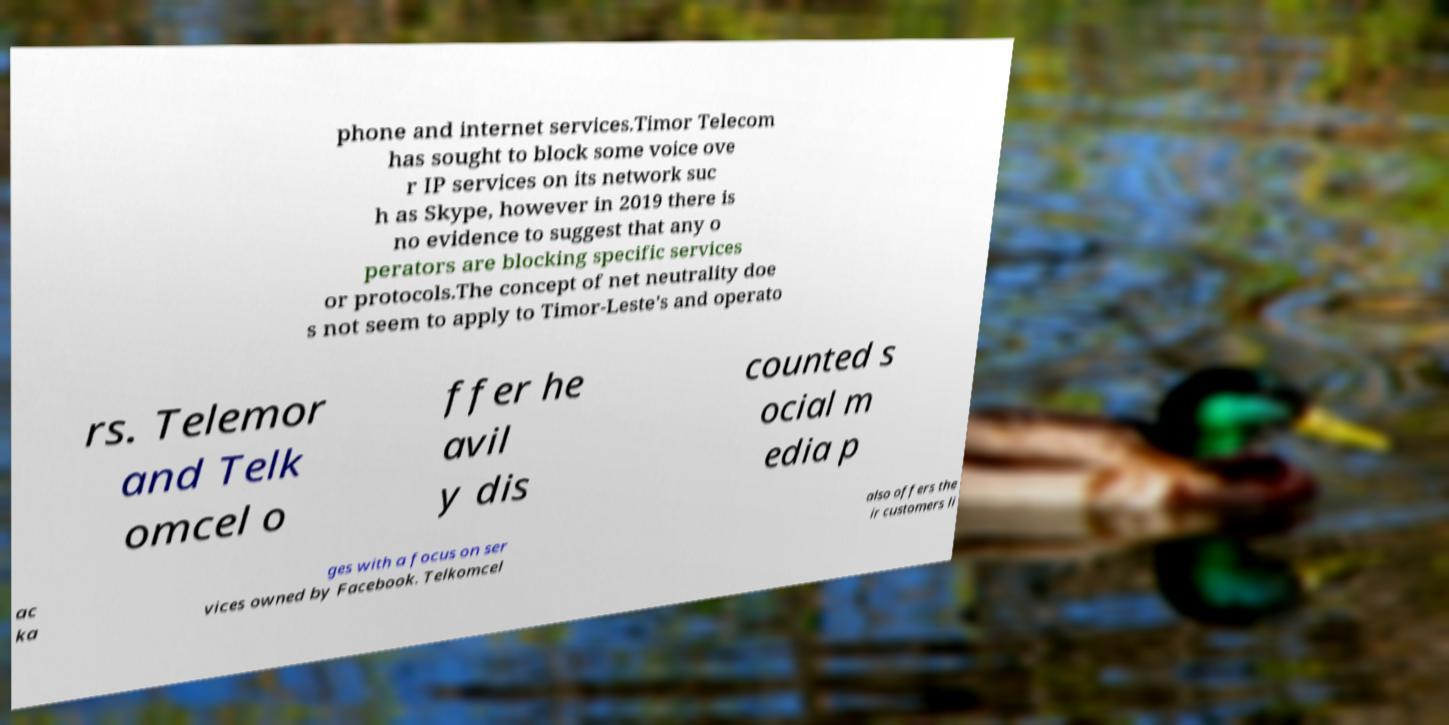Can you read and provide the text displayed in the image?This photo seems to have some interesting text. Can you extract and type it out for me? phone and internet services.Timor Telecom has sought to block some voice ove r IP services on its network suc h as Skype, however in 2019 there is no evidence to suggest that any o perators are blocking specific services or protocols.The concept of net neutrality doe s not seem to apply to Timor-Leste's and operato rs. Telemor and Telk omcel o ffer he avil y dis counted s ocial m edia p ac ka ges with a focus on ser vices owned by Facebook. Telkomcel also offers the ir customers li 